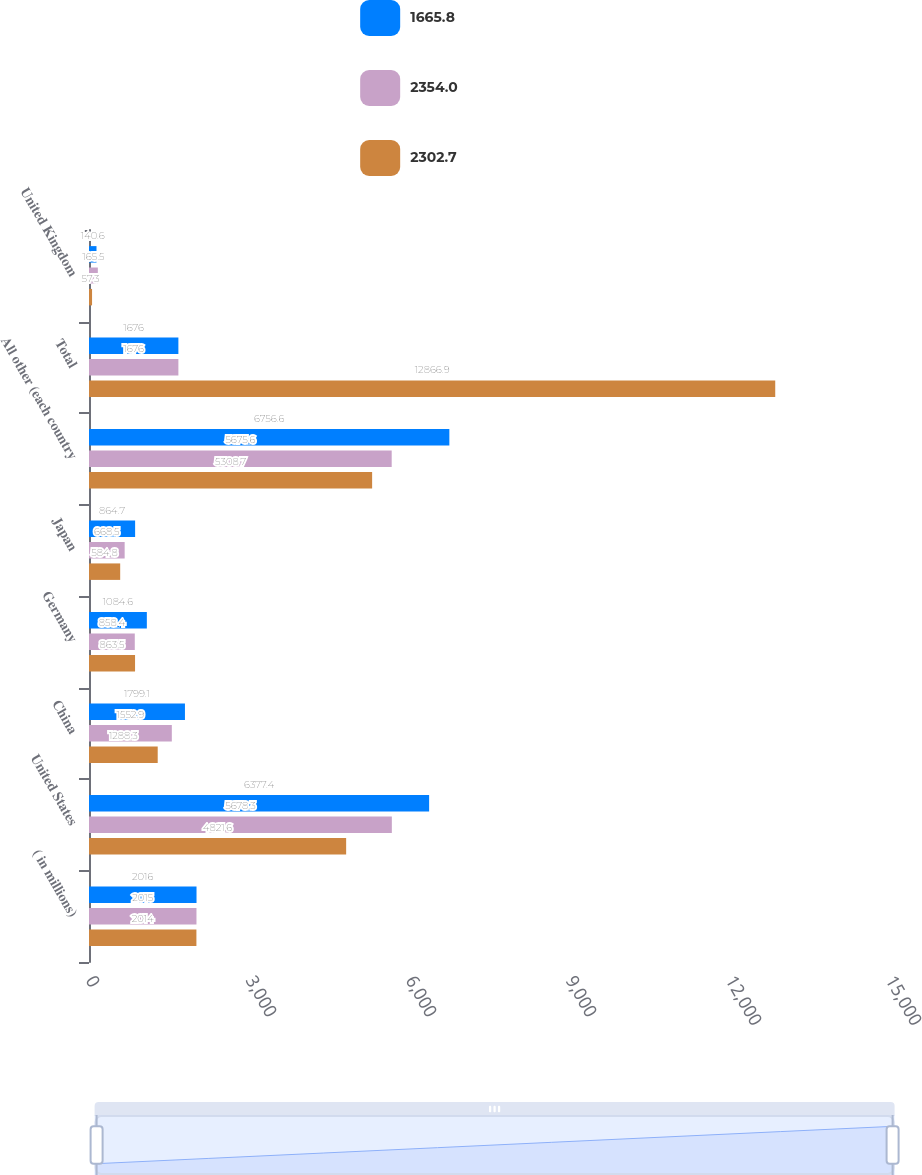Convert chart to OTSL. <chart><loc_0><loc_0><loc_500><loc_500><stacked_bar_chart><ecel><fcel>( in millions)<fcel>United States<fcel>China<fcel>Germany<fcel>Japan<fcel>All other (each country<fcel>Total<fcel>United Kingdom<nl><fcel>1665.8<fcel>2016<fcel>6377.4<fcel>1799.1<fcel>1084.6<fcel>864.7<fcel>6756.6<fcel>1676<fcel>140.6<nl><fcel>2354<fcel>2015<fcel>5678.3<fcel>1552.9<fcel>858.4<fcel>668.5<fcel>5675.6<fcel>1676<fcel>165.5<nl><fcel>2302.7<fcel>2014<fcel>4821.6<fcel>1288.3<fcel>863.5<fcel>584.8<fcel>5308.7<fcel>12866.9<fcel>57.3<nl></chart> 